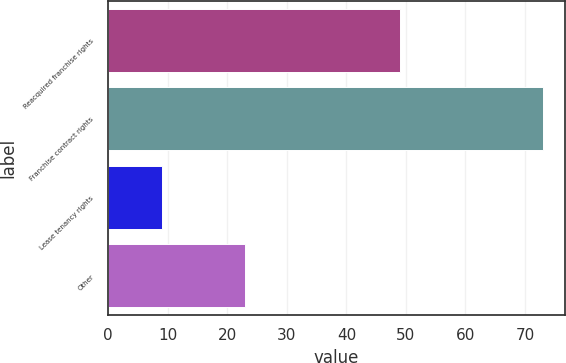Convert chart. <chart><loc_0><loc_0><loc_500><loc_500><bar_chart><fcel>Reacquired franchise rights<fcel>Franchise contract rights<fcel>Lease tenancy rights<fcel>Other<nl><fcel>49<fcel>73<fcel>9<fcel>23<nl></chart> 